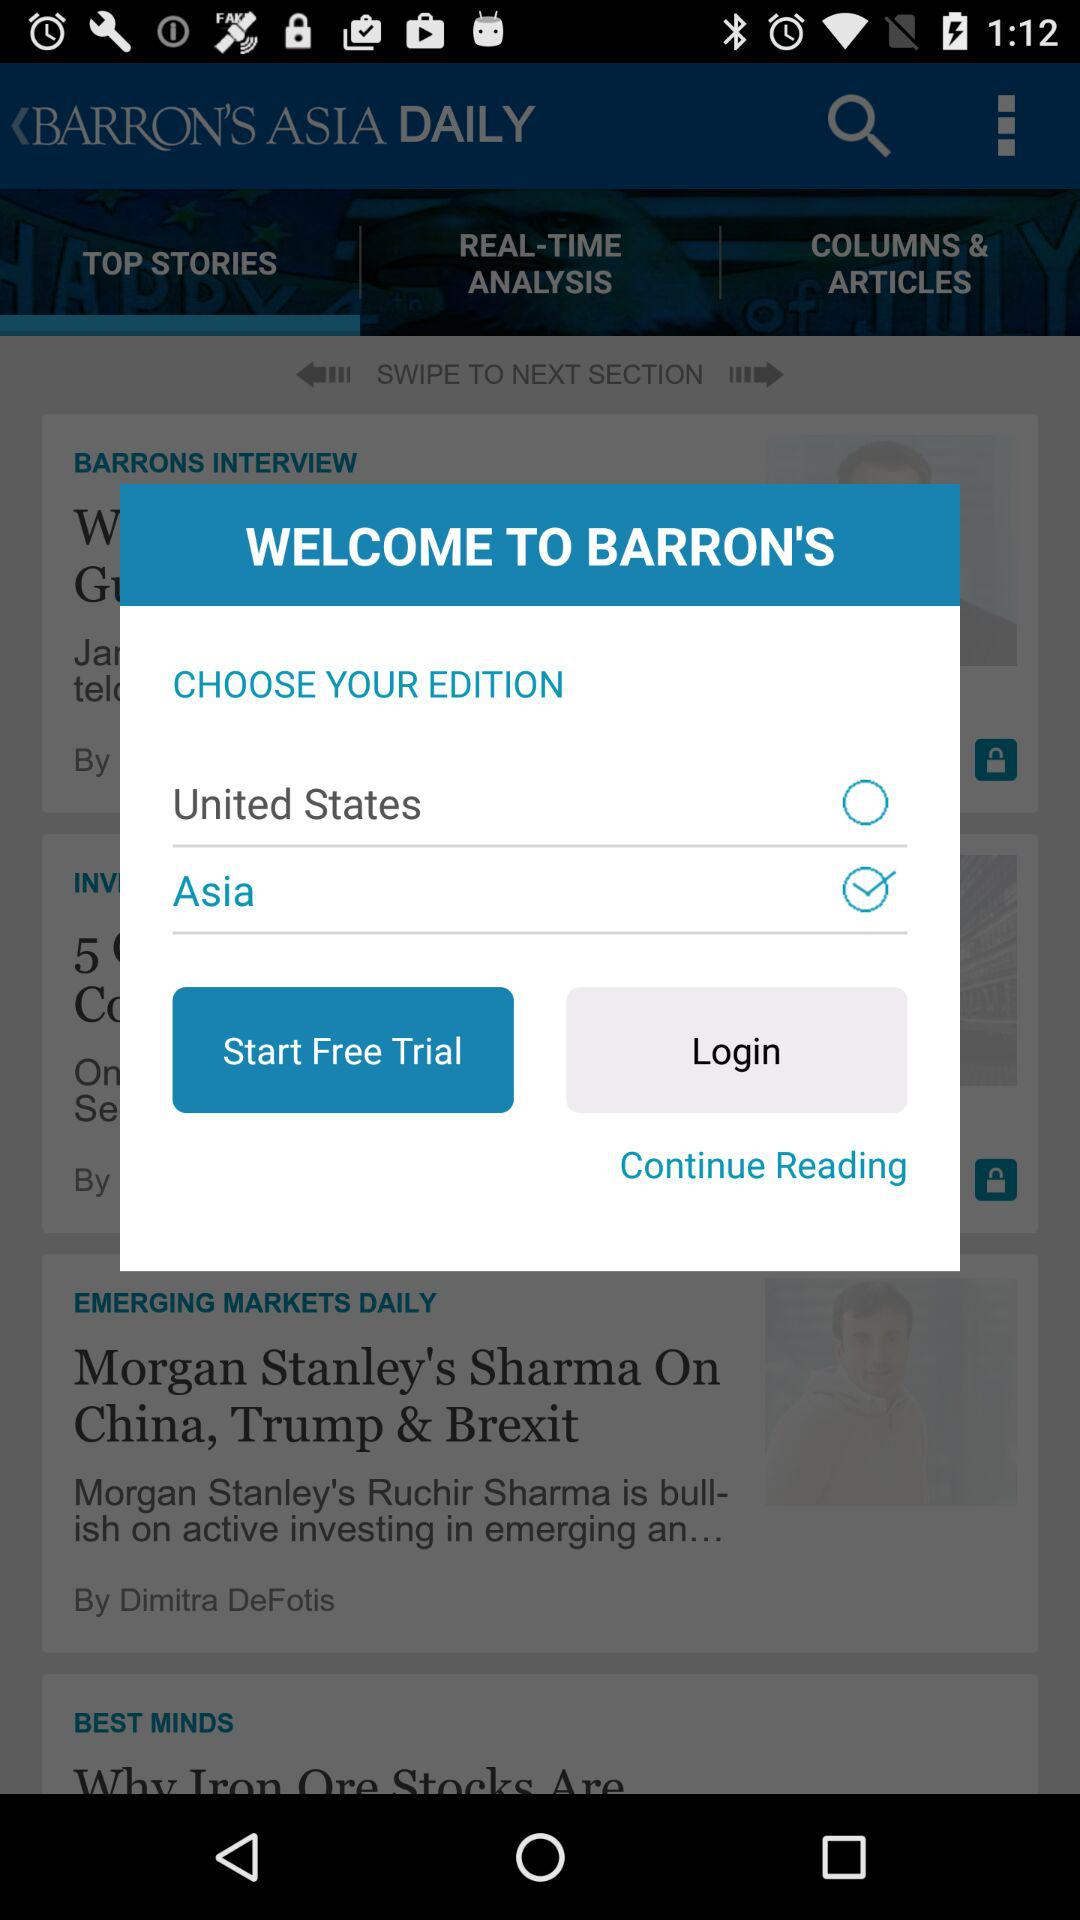Which edition is selected? The selected edition is "Asia". 